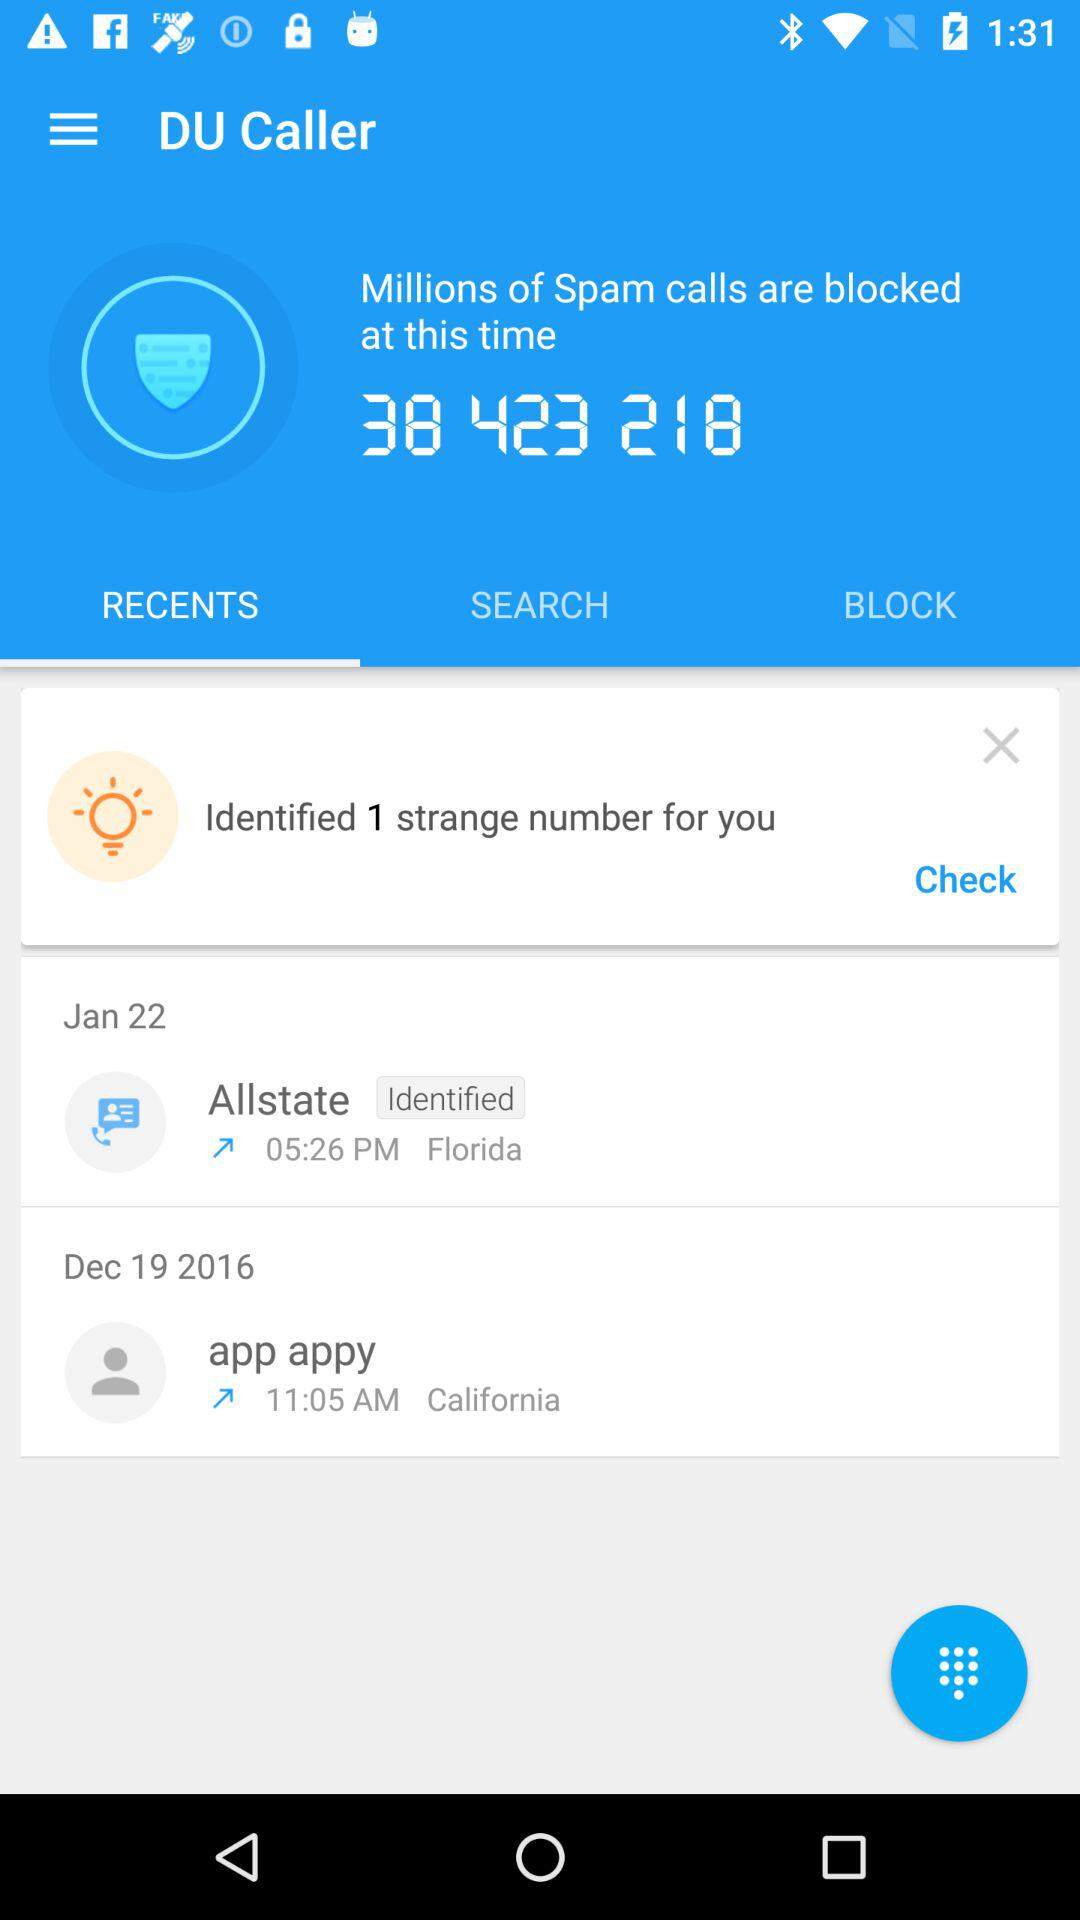What is the mentioned location in the "Allstate" log? The mentioned location in the "Allstate" log is Florida. 